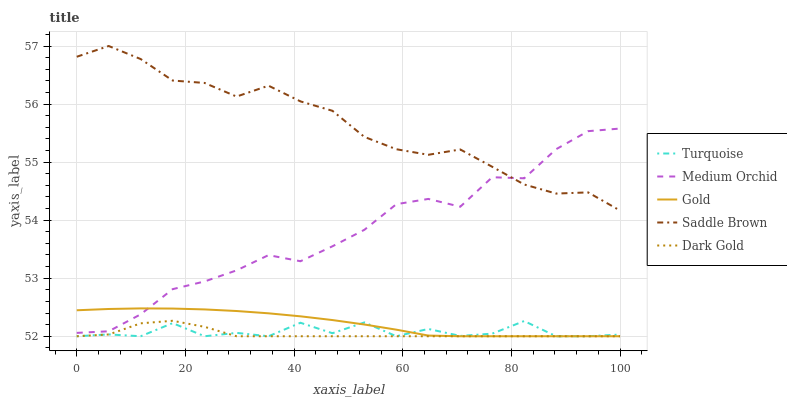Does Medium Orchid have the minimum area under the curve?
Answer yes or no. No. Does Medium Orchid have the maximum area under the curve?
Answer yes or no. No. Is Saddle Brown the smoothest?
Answer yes or no. No. Is Saddle Brown the roughest?
Answer yes or no. No. Does Medium Orchid have the lowest value?
Answer yes or no. No. Does Medium Orchid have the highest value?
Answer yes or no. No. Is Gold less than Saddle Brown?
Answer yes or no. Yes. Is Saddle Brown greater than Turquoise?
Answer yes or no. Yes. Does Gold intersect Saddle Brown?
Answer yes or no. No. 